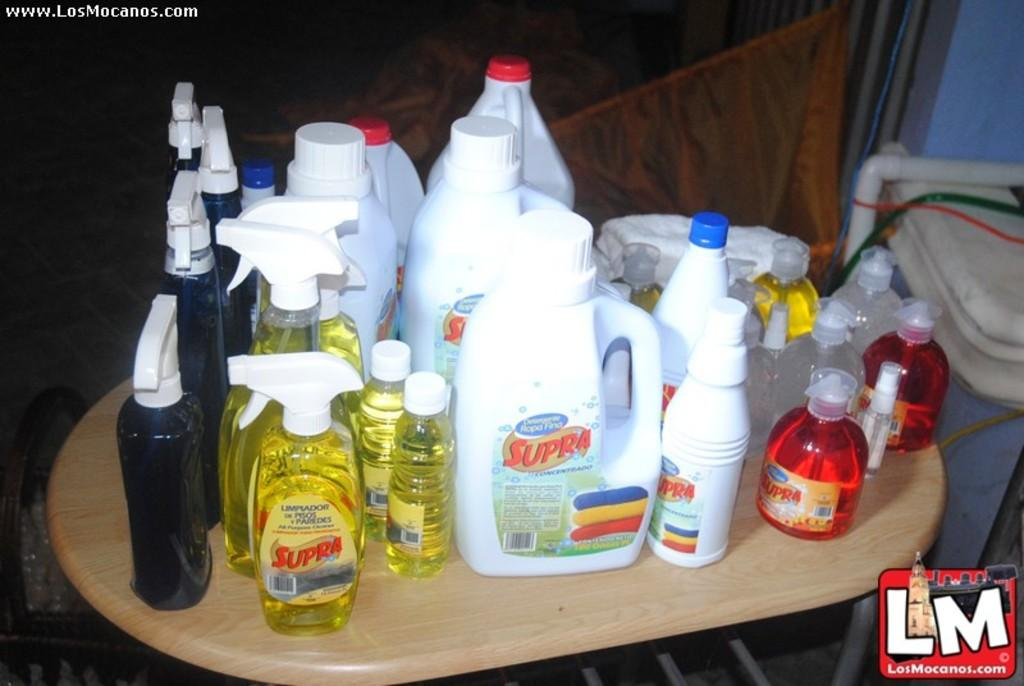<image>
Present a compact description of the photo's key features. Many bottles of cleaners are on a table including one with the brand name Supra. 